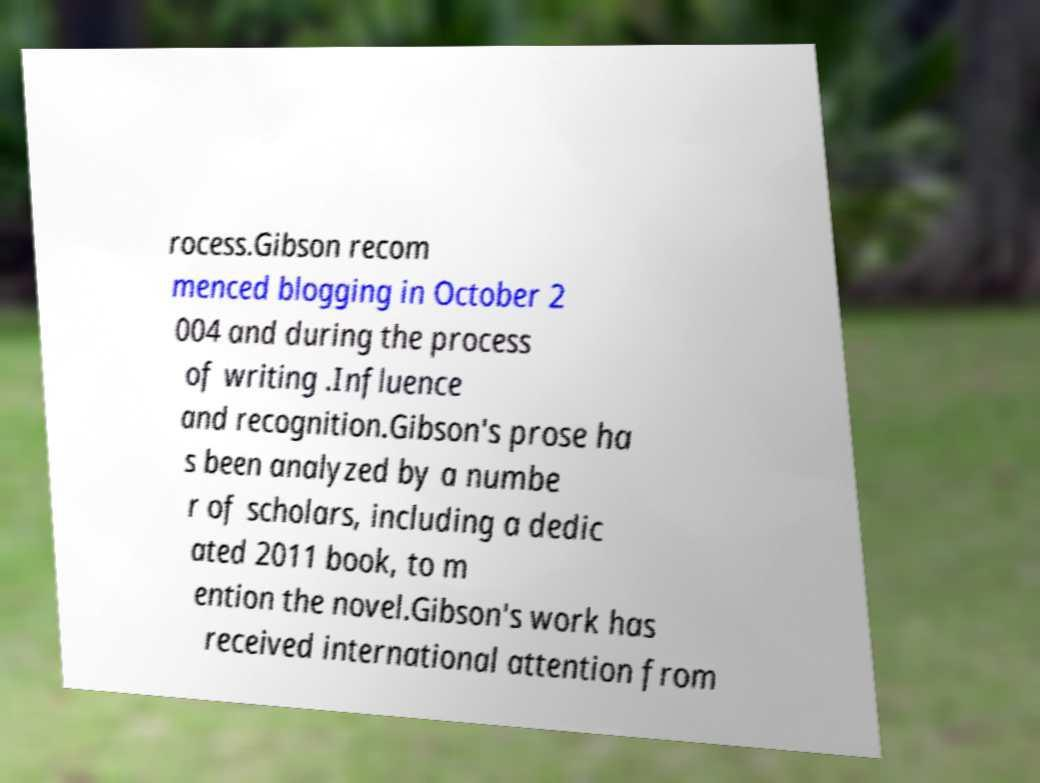For documentation purposes, I need the text within this image transcribed. Could you provide that? rocess.Gibson recom menced blogging in October 2 004 and during the process of writing .Influence and recognition.Gibson's prose ha s been analyzed by a numbe r of scholars, including a dedic ated 2011 book, to m ention the novel.Gibson's work has received international attention from 